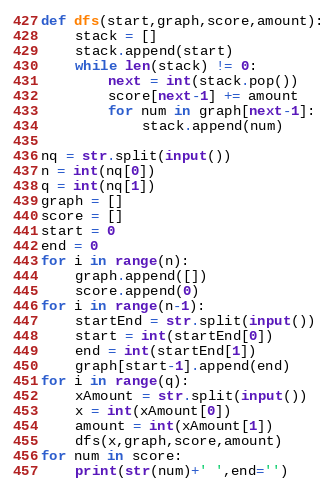<code> <loc_0><loc_0><loc_500><loc_500><_Python_>
def dfs(start,graph,score,amount):
    stack = []
    stack.append(start)
    while len(stack) != 0:
        next = int(stack.pop())
        score[next-1] += amount
        for num in graph[next-1]:
            stack.append(num)

nq = str.split(input())
n = int(nq[0])
q = int(nq[1])
graph = []
score = []
start = 0
end = 0
for i in range(n):
    graph.append([])
    score.append(0)
for i in range(n-1):
    startEnd = str.split(input())
    start = int(startEnd[0])
    end = int(startEnd[1])
    graph[start-1].append(end)
for i in range(q):
    xAmount = str.split(input())
    x = int(xAmount[0])
    amount = int(xAmount[1])
    dfs(x,graph,score,amount)
for num in score:
    print(str(num)+' ',end='')

</code> 